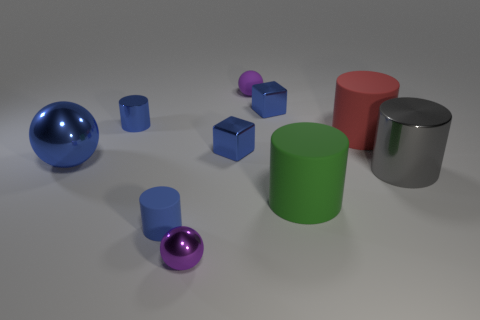Subtract all green cylinders. How many cylinders are left? 4 Subtract all large gray cylinders. How many cylinders are left? 4 Subtract all yellow cylinders. Subtract all red cubes. How many cylinders are left? 5 Subtract all blocks. How many objects are left? 8 Subtract 0 brown cylinders. How many objects are left? 10 Subtract all tiny blue cylinders. Subtract all big blue metal spheres. How many objects are left? 7 Add 5 blue shiny cylinders. How many blue shiny cylinders are left? 6 Add 4 brown metallic things. How many brown metallic things exist? 4 